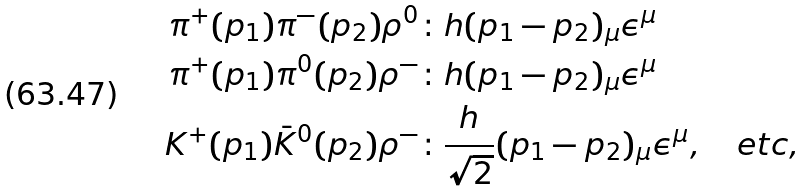Convert formula to latex. <formula><loc_0><loc_0><loc_500><loc_500>\pi ^ { + } ( p _ { 1 } ) \pi ^ { - } ( p _ { 2 } ) \rho ^ { 0 } & \colon h ( p _ { 1 } - p _ { 2 } ) _ { \mu } \epsilon ^ { \mu } \\ \pi ^ { + } ( p _ { 1 } ) \pi ^ { 0 } ( p _ { 2 } ) \rho ^ { - } & \colon h ( p _ { 1 } - p _ { 2 } ) _ { \mu } \epsilon ^ { \mu } \\ K ^ { + } ( p _ { 1 } ) \bar { K } ^ { 0 } ( p _ { 2 } ) \rho ^ { - } & \colon \frac { h } { \sqrt { 2 } } ( p _ { 1 } - p _ { 2 } ) _ { \mu } \epsilon ^ { \mu } , \quad e t c ,</formula> 